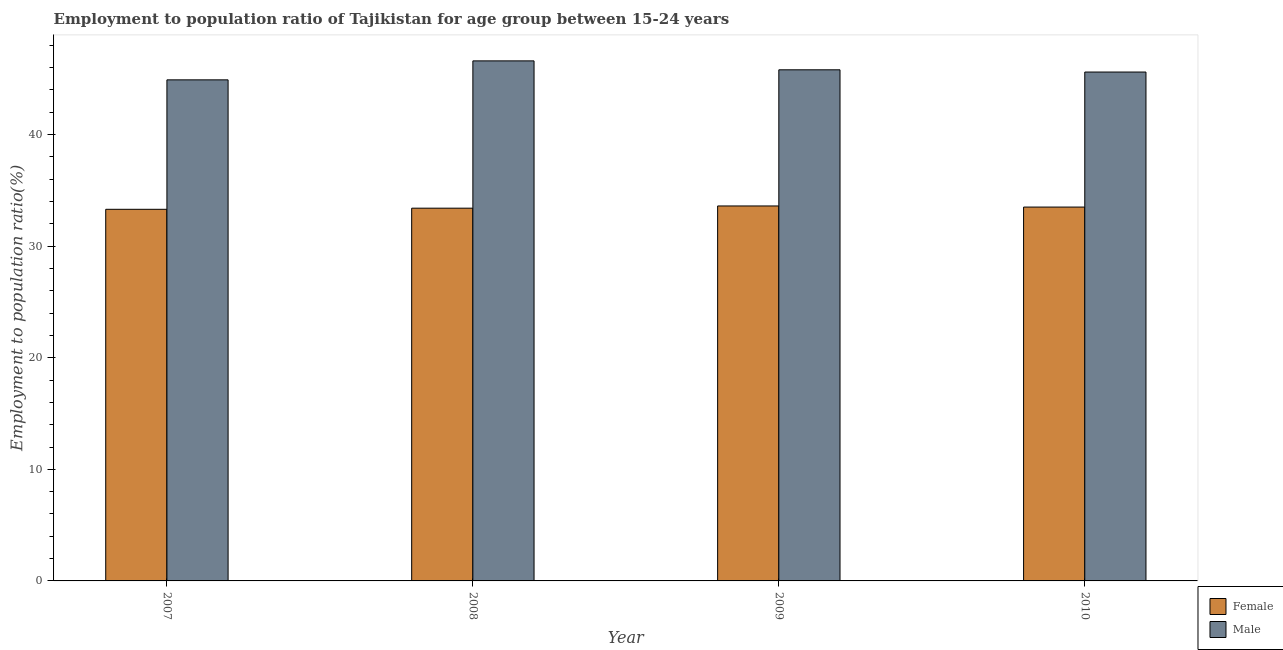How many groups of bars are there?
Offer a very short reply. 4. Are the number of bars per tick equal to the number of legend labels?
Your answer should be very brief. Yes. What is the label of the 1st group of bars from the left?
Ensure brevity in your answer.  2007. In how many cases, is the number of bars for a given year not equal to the number of legend labels?
Make the answer very short. 0. What is the employment to population ratio(male) in 2007?
Make the answer very short. 44.9. Across all years, what is the maximum employment to population ratio(female)?
Provide a succinct answer. 33.6. Across all years, what is the minimum employment to population ratio(male)?
Provide a succinct answer. 44.9. In which year was the employment to population ratio(male) maximum?
Provide a succinct answer. 2008. What is the total employment to population ratio(male) in the graph?
Provide a succinct answer. 182.9. What is the difference between the employment to population ratio(male) in 2008 and that in 2010?
Make the answer very short. 1. What is the difference between the employment to population ratio(female) in 2010 and the employment to population ratio(male) in 2007?
Your response must be concise. 0.2. What is the average employment to population ratio(male) per year?
Your answer should be compact. 45.72. In the year 2008, what is the difference between the employment to population ratio(male) and employment to population ratio(female)?
Give a very brief answer. 0. In how many years, is the employment to population ratio(female) greater than 38 %?
Keep it short and to the point. 0. What is the ratio of the employment to population ratio(male) in 2008 to that in 2010?
Your response must be concise. 1.02. Is the employment to population ratio(female) in 2008 less than that in 2009?
Keep it short and to the point. Yes. Is the difference between the employment to population ratio(male) in 2008 and 2010 greater than the difference between the employment to population ratio(female) in 2008 and 2010?
Keep it short and to the point. No. What is the difference between the highest and the second highest employment to population ratio(male)?
Your answer should be very brief. 0.8. What is the difference between the highest and the lowest employment to population ratio(male)?
Make the answer very short. 1.7. Is the sum of the employment to population ratio(female) in 2009 and 2010 greater than the maximum employment to population ratio(male) across all years?
Offer a terse response. Yes. What does the 1st bar from the left in 2010 represents?
Provide a short and direct response. Female. How many bars are there?
Ensure brevity in your answer.  8. Are all the bars in the graph horizontal?
Keep it short and to the point. No. Are the values on the major ticks of Y-axis written in scientific E-notation?
Ensure brevity in your answer.  No. Where does the legend appear in the graph?
Keep it short and to the point. Bottom right. How many legend labels are there?
Provide a succinct answer. 2. How are the legend labels stacked?
Keep it short and to the point. Vertical. What is the title of the graph?
Your response must be concise. Employment to population ratio of Tajikistan for age group between 15-24 years. Does "Central government" appear as one of the legend labels in the graph?
Provide a succinct answer. No. What is the Employment to population ratio(%) of Female in 2007?
Give a very brief answer. 33.3. What is the Employment to population ratio(%) of Male in 2007?
Provide a succinct answer. 44.9. What is the Employment to population ratio(%) in Female in 2008?
Your answer should be compact. 33.4. What is the Employment to population ratio(%) in Male in 2008?
Provide a succinct answer. 46.6. What is the Employment to population ratio(%) in Female in 2009?
Ensure brevity in your answer.  33.6. What is the Employment to population ratio(%) of Male in 2009?
Give a very brief answer. 45.8. What is the Employment to population ratio(%) in Female in 2010?
Keep it short and to the point. 33.5. What is the Employment to population ratio(%) of Male in 2010?
Keep it short and to the point. 45.6. Across all years, what is the maximum Employment to population ratio(%) of Female?
Ensure brevity in your answer.  33.6. Across all years, what is the maximum Employment to population ratio(%) in Male?
Your answer should be compact. 46.6. Across all years, what is the minimum Employment to population ratio(%) in Female?
Your answer should be compact. 33.3. Across all years, what is the minimum Employment to population ratio(%) of Male?
Your response must be concise. 44.9. What is the total Employment to population ratio(%) of Female in the graph?
Make the answer very short. 133.8. What is the total Employment to population ratio(%) of Male in the graph?
Your answer should be compact. 182.9. What is the difference between the Employment to population ratio(%) of Female in 2007 and that in 2008?
Your answer should be compact. -0.1. What is the difference between the Employment to population ratio(%) of Male in 2007 and that in 2009?
Make the answer very short. -0.9. What is the difference between the Employment to population ratio(%) of Male in 2007 and that in 2010?
Give a very brief answer. -0.7. What is the difference between the Employment to population ratio(%) of Male in 2008 and that in 2009?
Keep it short and to the point. 0.8. What is the difference between the Employment to population ratio(%) in Female in 2009 and that in 2010?
Ensure brevity in your answer.  0.1. What is the difference between the Employment to population ratio(%) in Male in 2009 and that in 2010?
Ensure brevity in your answer.  0.2. What is the difference between the Employment to population ratio(%) in Female in 2007 and the Employment to population ratio(%) in Male in 2008?
Offer a terse response. -13.3. What is the difference between the Employment to population ratio(%) of Female in 2007 and the Employment to population ratio(%) of Male in 2010?
Your answer should be compact. -12.3. What is the difference between the Employment to population ratio(%) of Female in 2008 and the Employment to population ratio(%) of Male in 2009?
Your answer should be compact. -12.4. What is the difference between the Employment to population ratio(%) of Female in 2008 and the Employment to population ratio(%) of Male in 2010?
Ensure brevity in your answer.  -12.2. What is the difference between the Employment to population ratio(%) in Female in 2009 and the Employment to population ratio(%) in Male in 2010?
Give a very brief answer. -12. What is the average Employment to population ratio(%) of Female per year?
Provide a short and direct response. 33.45. What is the average Employment to population ratio(%) in Male per year?
Make the answer very short. 45.73. In the year 2008, what is the difference between the Employment to population ratio(%) of Female and Employment to population ratio(%) of Male?
Provide a succinct answer. -13.2. What is the ratio of the Employment to population ratio(%) in Female in 2007 to that in 2008?
Offer a terse response. 1. What is the ratio of the Employment to population ratio(%) in Male in 2007 to that in 2008?
Your response must be concise. 0.96. What is the ratio of the Employment to population ratio(%) in Male in 2007 to that in 2009?
Ensure brevity in your answer.  0.98. What is the ratio of the Employment to population ratio(%) in Male in 2007 to that in 2010?
Offer a very short reply. 0.98. What is the ratio of the Employment to population ratio(%) in Female in 2008 to that in 2009?
Provide a succinct answer. 0.99. What is the ratio of the Employment to population ratio(%) of Male in 2008 to that in 2009?
Give a very brief answer. 1.02. What is the ratio of the Employment to population ratio(%) of Male in 2008 to that in 2010?
Provide a short and direct response. 1.02. What is the ratio of the Employment to population ratio(%) in Male in 2009 to that in 2010?
Your answer should be compact. 1. What is the difference between the highest and the second highest Employment to population ratio(%) of Female?
Keep it short and to the point. 0.1. What is the difference between the highest and the lowest Employment to population ratio(%) of Female?
Provide a succinct answer. 0.3. 